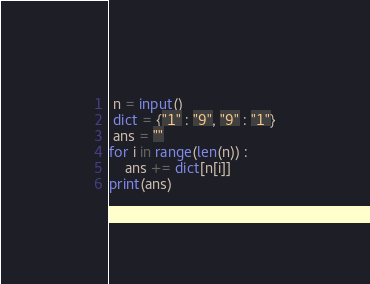Convert code to text. <code><loc_0><loc_0><loc_500><loc_500><_Python_> n = input()
 dict = {"1" : "9", "9" : "1"}
 ans = ""
for i in range(len(n)) :
    ans += dict[n[i]]
print(ans)</code> 